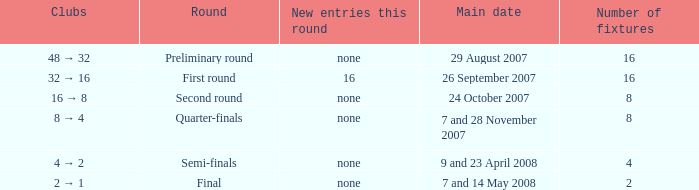What is the Round when the number of fixtures is more than 2, and the Main date of 7 and 28 november 2007? Quarter-finals. 